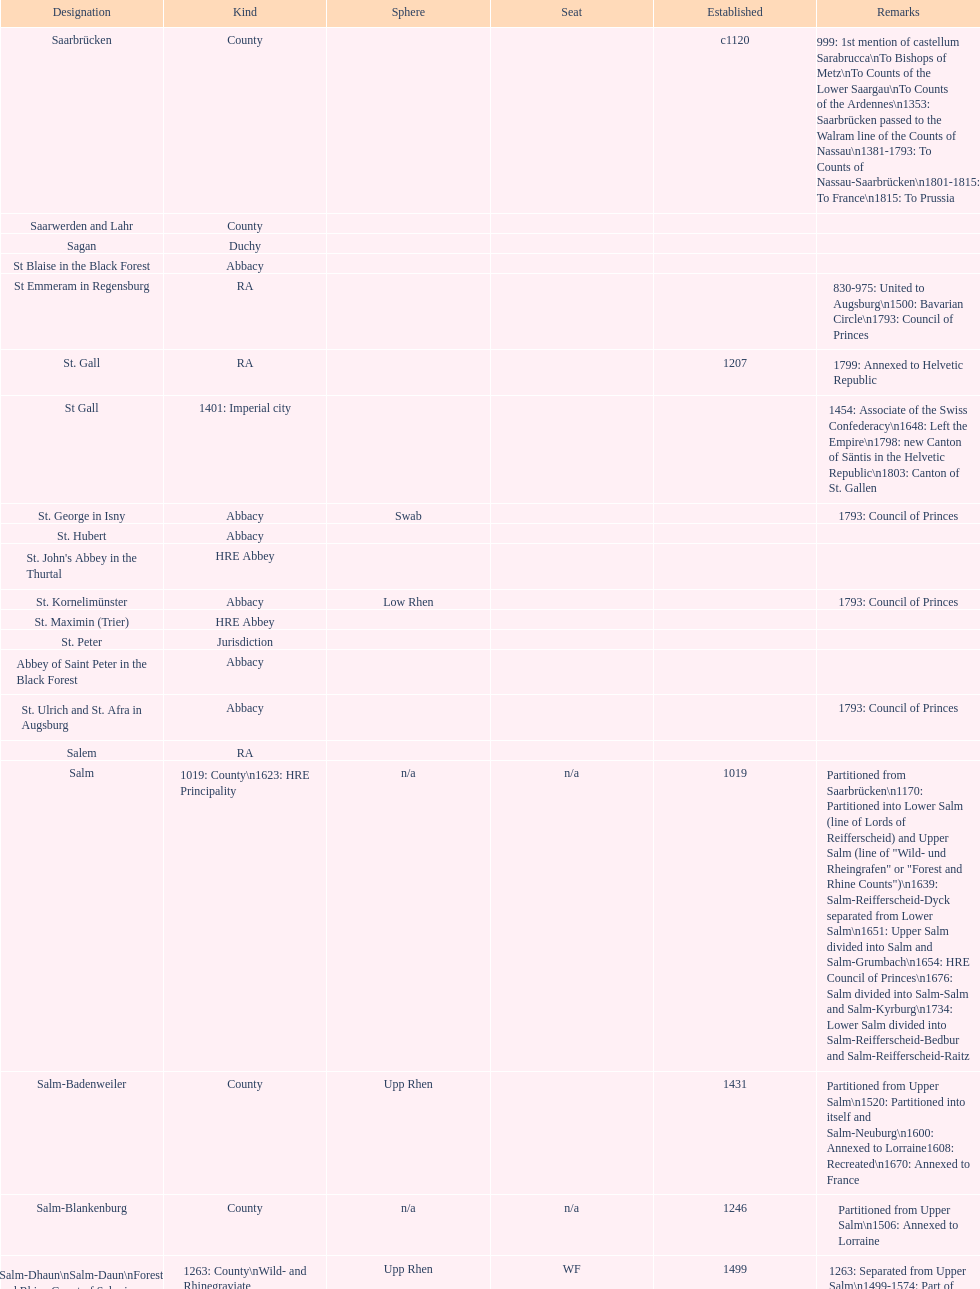What is the state above "sagan"? Saarwerden and Lahr. 